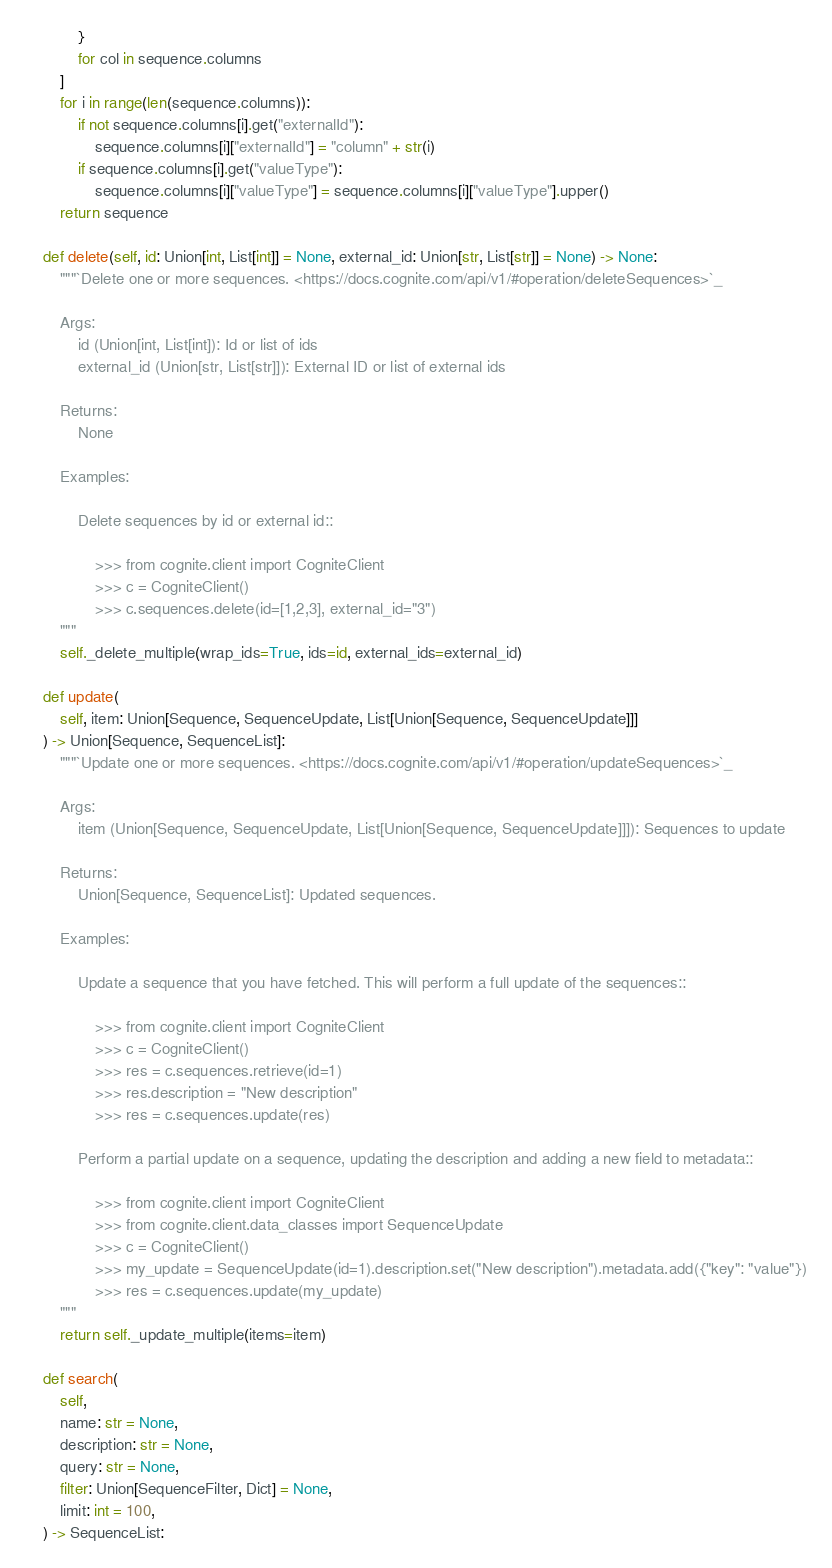<code> <loc_0><loc_0><loc_500><loc_500><_Python_>            }
            for col in sequence.columns
        ]
        for i in range(len(sequence.columns)):
            if not sequence.columns[i].get("externalId"):
                sequence.columns[i]["externalId"] = "column" + str(i)
            if sequence.columns[i].get("valueType"):
                sequence.columns[i]["valueType"] = sequence.columns[i]["valueType"].upper()
        return sequence

    def delete(self, id: Union[int, List[int]] = None, external_id: Union[str, List[str]] = None) -> None:
        """`Delete one or more sequences. <https://docs.cognite.com/api/v1/#operation/deleteSequences>`_

        Args:
            id (Union[int, List[int]): Id or list of ids
            external_id (Union[str, List[str]]): External ID or list of external ids

        Returns:
            None

        Examples:

            Delete sequences by id or external id::

                >>> from cognite.client import CogniteClient
                >>> c = CogniteClient()
                >>> c.sequences.delete(id=[1,2,3], external_id="3")
        """
        self._delete_multiple(wrap_ids=True, ids=id, external_ids=external_id)

    def update(
        self, item: Union[Sequence, SequenceUpdate, List[Union[Sequence, SequenceUpdate]]]
    ) -> Union[Sequence, SequenceList]:
        """`Update one or more sequences. <https://docs.cognite.com/api/v1/#operation/updateSequences>`_

        Args:
            item (Union[Sequence, SequenceUpdate, List[Union[Sequence, SequenceUpdate]]]): Sequences to update

        Returns:
            Union[Sequence, SequenceList]: Updated sequences.

        Examples:

            Update a sequence that you have fetched. This will perform a full update of the sequences::

                >>> from cognite.client import CogniteClient
                >>> c = CogniteClient()
                >>> res = c.sequences.retrieve(id=1)
                >>> res.description = "New description"
                >>> res = c.sequences.update(res)

            Perform a partial update on a sequence, updating the description and adding a new field to metadata::

                >>> from cognite.client import CogniteClient
                >>> from cognite.client.data_classes import SequenceUpdate
                >>> c = CogniteClient()
                >>> my_update = SequenceUpdate(id=1).description.set("New description").metadata.add({"key": "value"})
                >>> res = c.sequences.update(my_update)
        """
        return self._update_multiple(items=item)

    def search(
        self,
        name: str = None,
        description: str = None,
        query: str = None,
        filter: Union[SequenceFilter, Dict] = None,
        limit: int = 100,
    ) -> SequenceList:</code> 